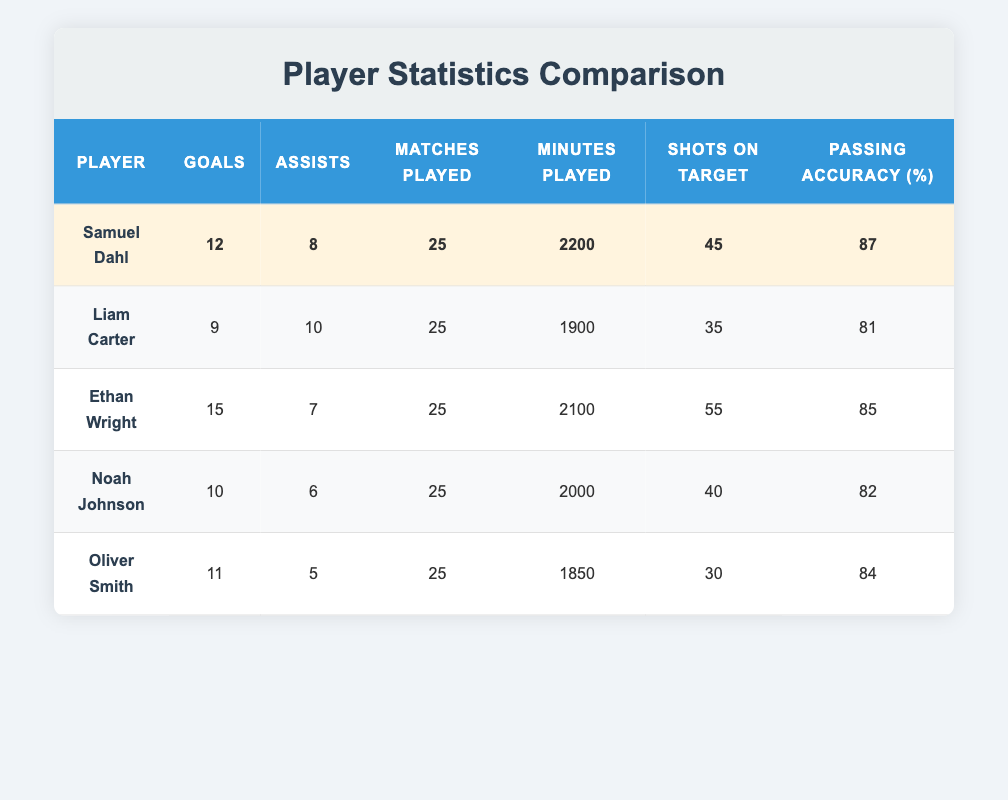What is the total number of goals scored by Samuel Dahl and Ethan Wright combined? To find the total goals, we add Samuel Dahl's goals (12) and Ethan Wright's goals (15). So, 12 + 15 = 27.
Answer: 27 How many assists did Liam Carter provide compared to Oliver Smith? Liam Carter provided 10 assists while Oliver Smith provided 5 assists. The difference is 10 - 5 = 5.
Answer: 5 Is Noah Johnson's passing accuracy greater than Samuel Dahl's? Samuel Dahl's passing accuracy is 87%, and Noah Johnson's is 82%. Since 87 is greater than 82, the answer is yes.
Answer: Yes What is the average number of matches played by all players? All players have played the same number of matches, which is 25. Therefore, the average is also 25 since every player contributed equally.
Answer: 25 Who has the most shots on target, and how many did they have? Among the players, Ethan Wright has the most shots on target with 55. We check each player's shots on target, confirming Ethan has the highest number.
Answer: 55 What is the combined total of minutes played by Samuel Dahl and Noah Johnson? We sum Samuel Dahl's minutes (2200) and Noah Johnson's minutes (2000), giving us 2200 + 2000 = 4200 minutes.
Answer: 4200 Did any player score more goals than Samuel Dahl? Samuel Dahl has 12 goals. The only player with more goals is Ethan Wright, who scored 15 goals. Therefore, the answer is yes.
Answer: Yes What is the difference in passing accuracy between the player with the most goals and the player with the least goals? The player with the most goals is Ethan Wright (15 goals) and the player with the least goals is Liam Carter (9 goals). Their passing accuracies are 85% and 81%, respectively. The difference is 85 - 81 = 4%.
Answer: 4% 